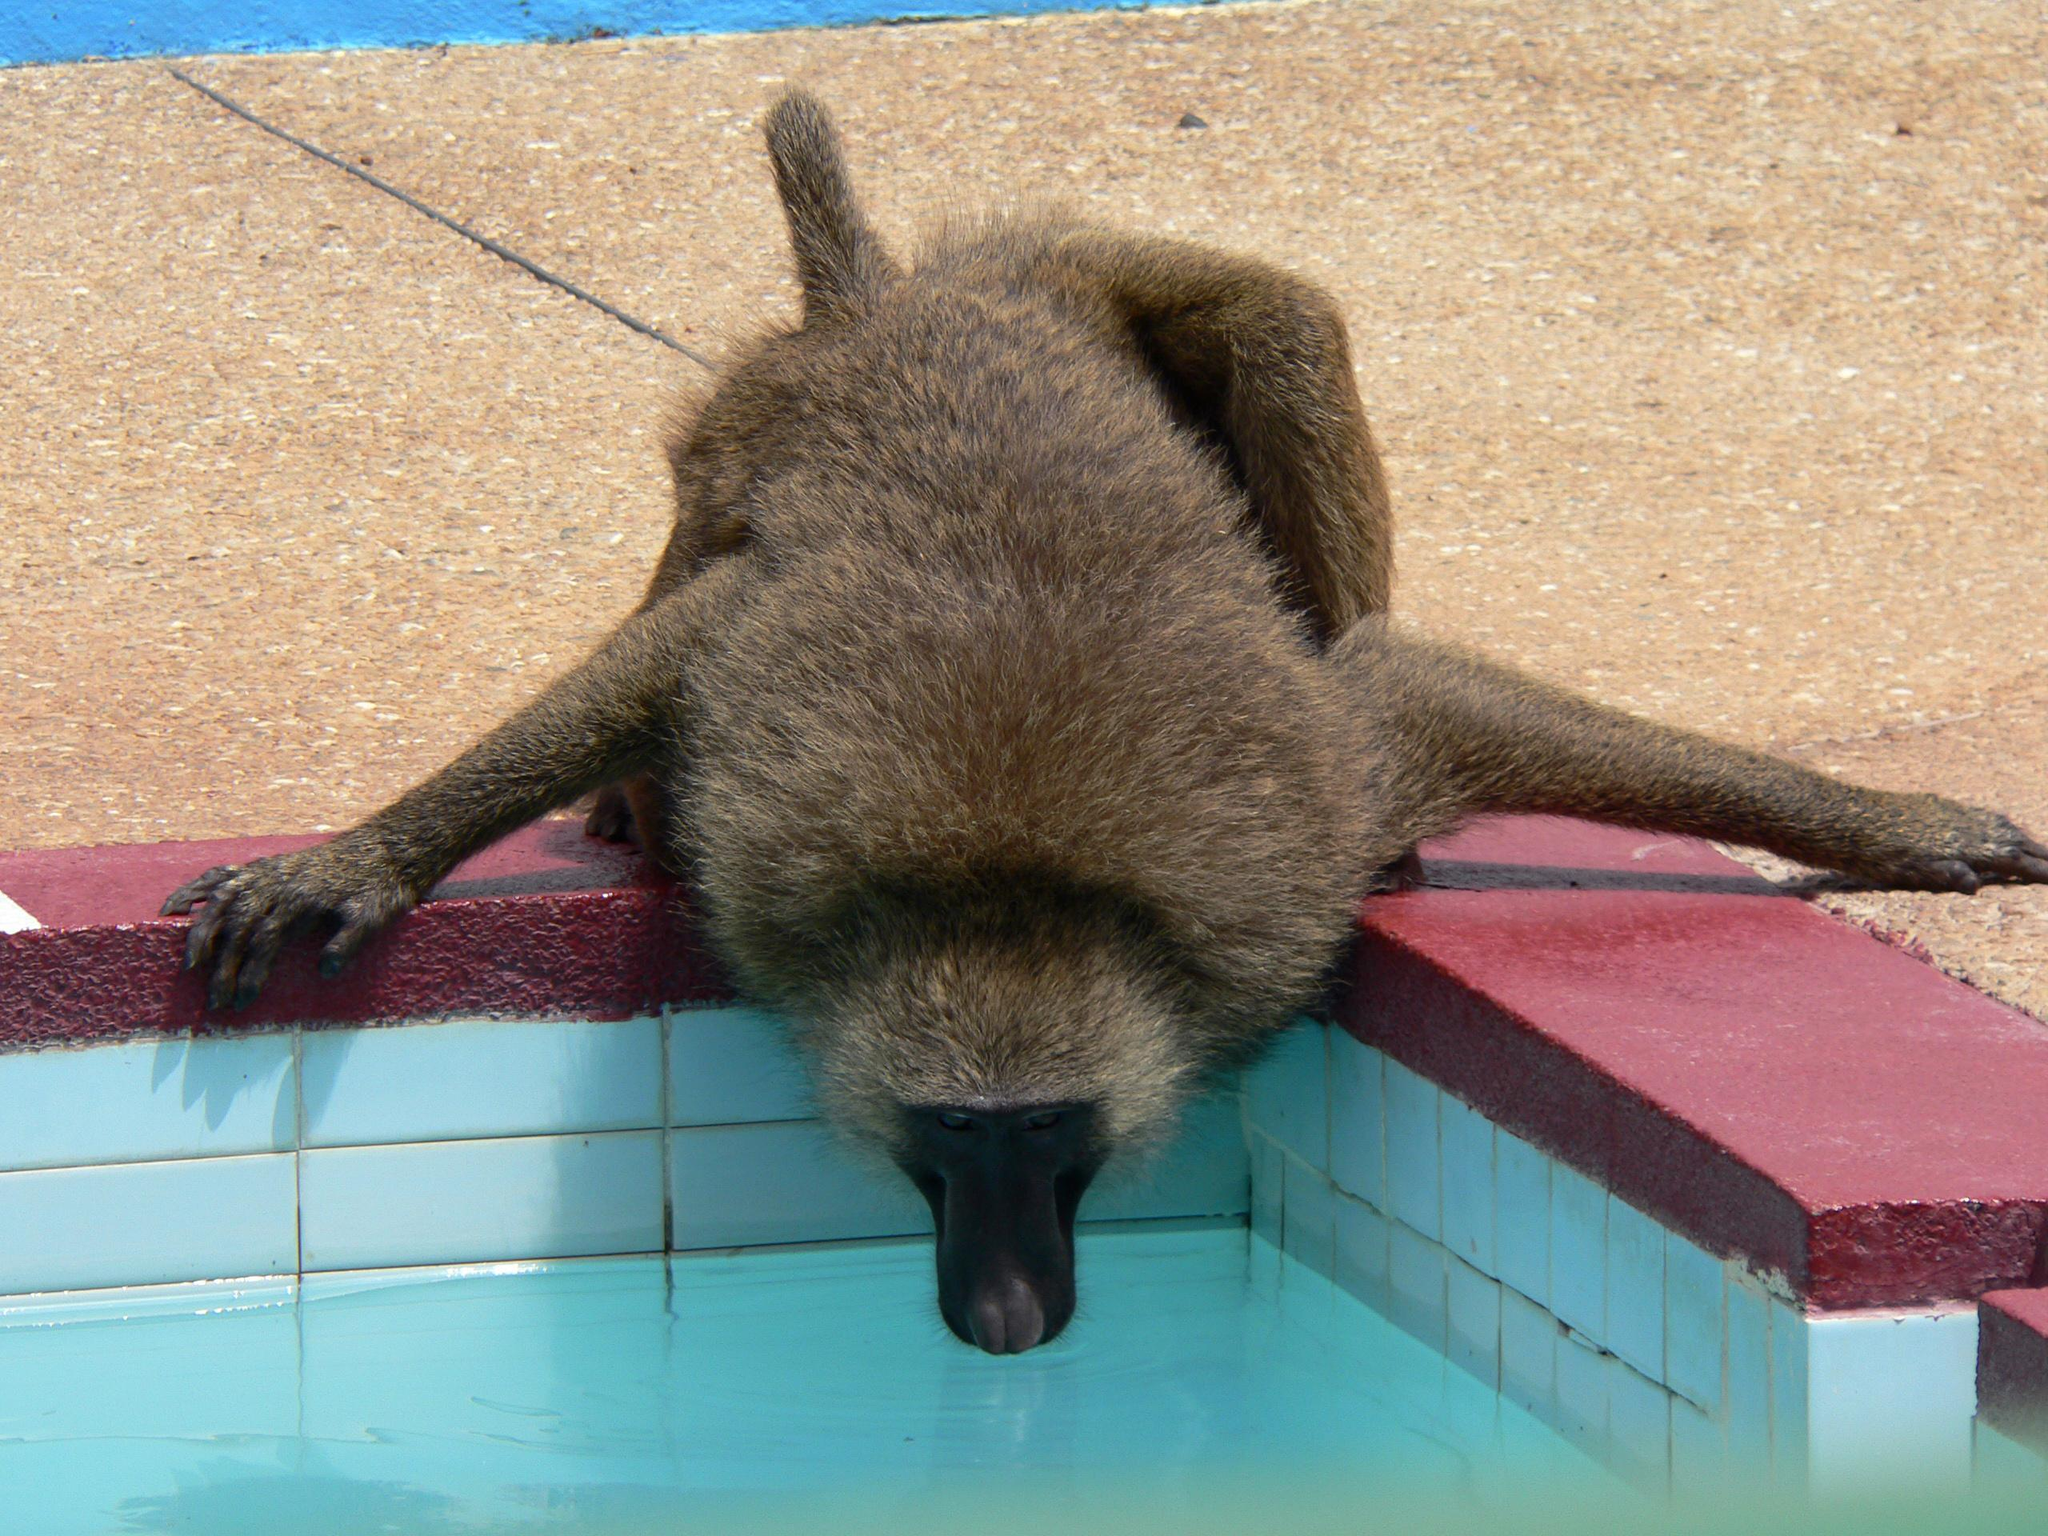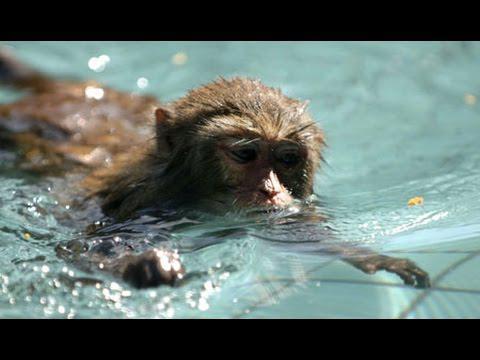The first image is the image on the left, the second image is the image on the right. Examine the images to the left and right. Is the description "The left image includes at least one baboon perched on a cement ledge next to water, and the right image includes at least one baboon neck-deep in water." accurate? Answer yes or no. Yes. The first image is the image on the left, the second image is the image on the right. For the images shown, is this caption "The monkey in the right image is in the water." true? Answer yes or no. Yes. 